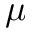<formula> <loc_0><loc_0><loc_500><loc_500>\mu</formula> 